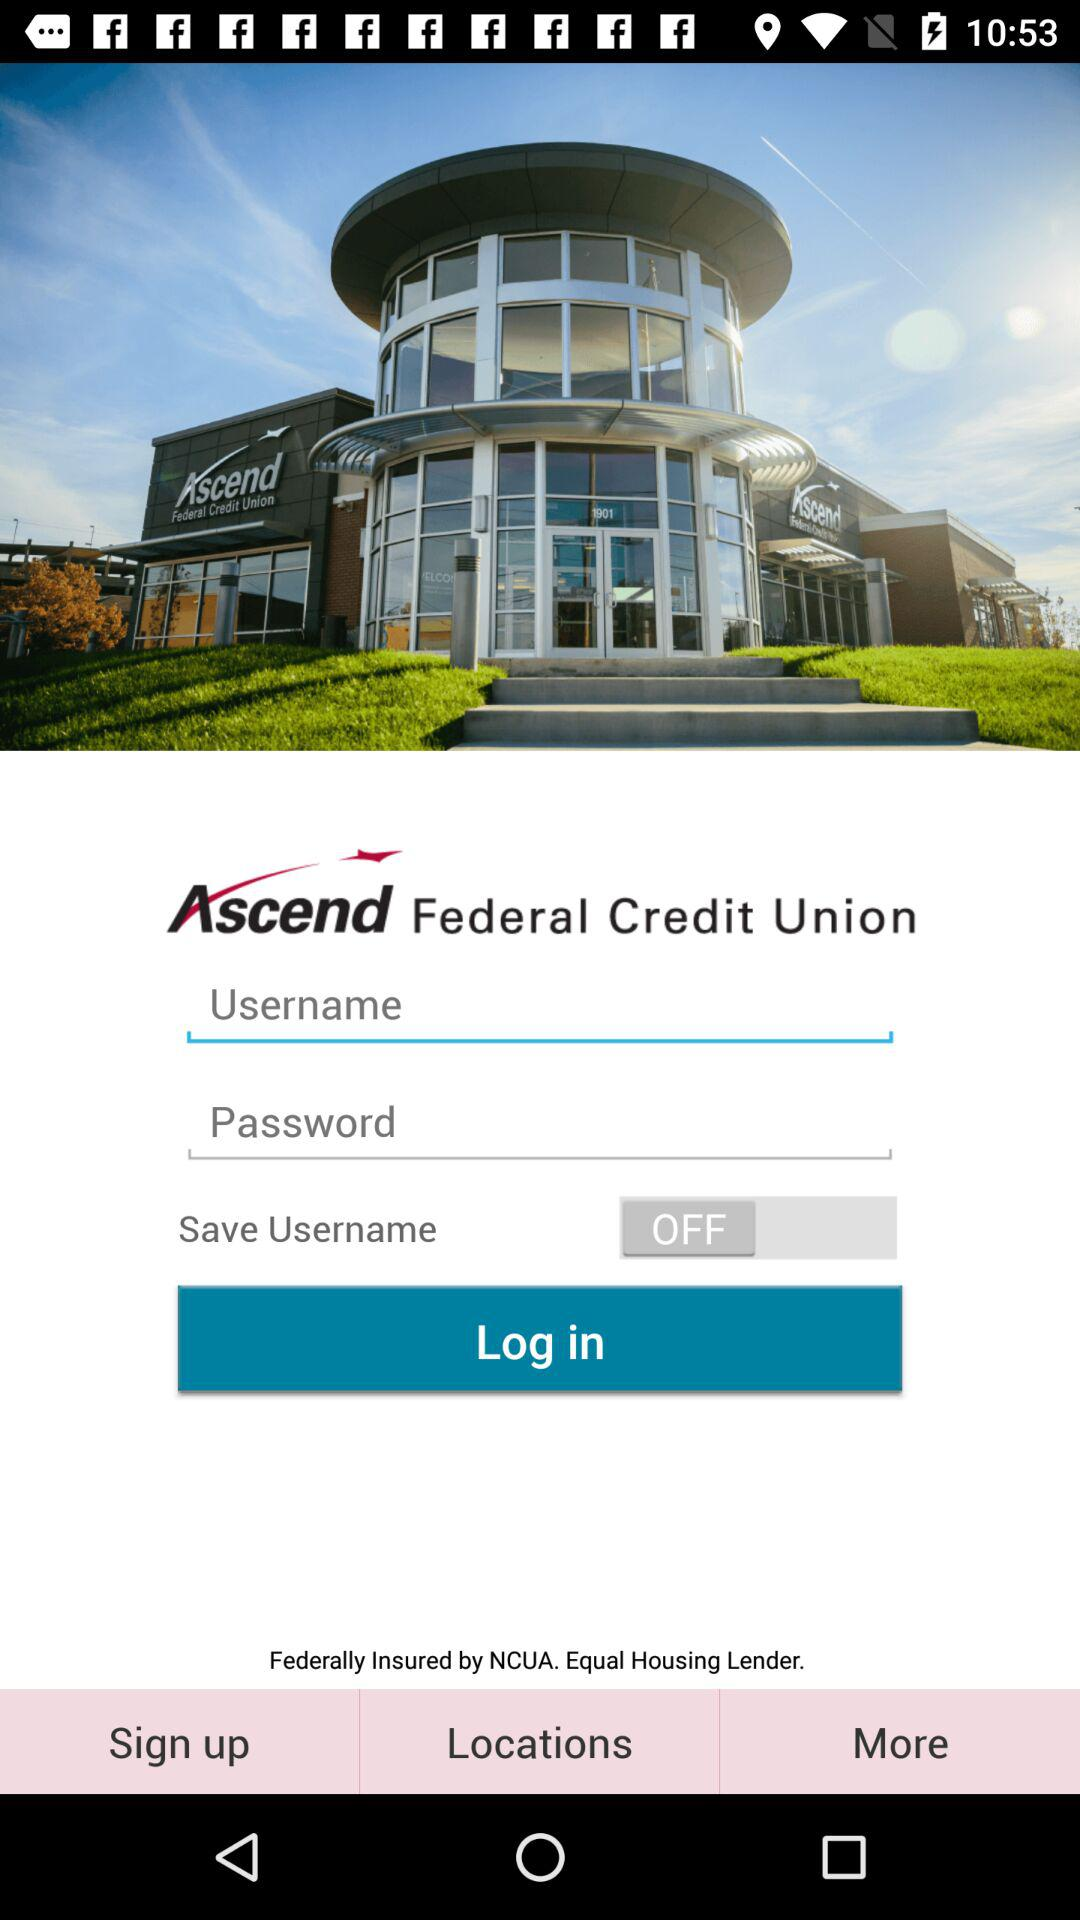What is the status of "Save Username"? The status of "Save Username" is "off". 